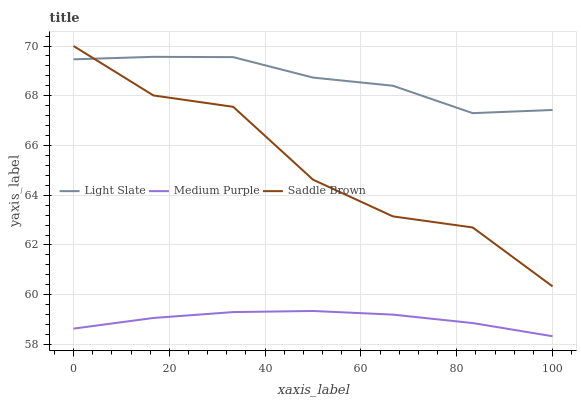Does Medium Purple have the minimum area under the curve?
Answer yes or no. Yes. Does Light Slate have the maximum area under the curve?
Answer yes or no. Yes. Does Saddle Brown have the minimum area under the curve?
Answer yes or no. No. Does Saddle Brown have the maximum area under the curve?
Answer yes or no. No. Is Medium Purple the smoothest?
Answer yes or no. Yes. Is Saddle Brown the roughest?
Answer yes or no. Yes. Is Saddle Brown the smoothest?
Answer yes or no. No. Is Medium Purple the roughest?
Answer yes or no. No. Does Medium Purple have the lowest value?
Answer yes or no. Yes. Does Saddle Brown have the lowest value?
Answer yes or no. No. Does Saddle Brown have the highest value?
Answer yes or no. Yes. Does Medium Purple have the highest value?
Answer yes or no. No. Is Medium Purple less than Light Slate?
Answer yes or no. Yes. Is Light Slate greater than Medium Purple?
Answer yes or no. Yes. Does Light Slate intersect Saddle Brown?
Answer yes or no. Yes. Is Light Slate less than Saddle Brown?
Answer yes or no. No. Is Light Slate greater than Saddle Brown?
Answer yes or no. No. Does Medium Purple intersect Light Slate?
Answer yes or no. No. 